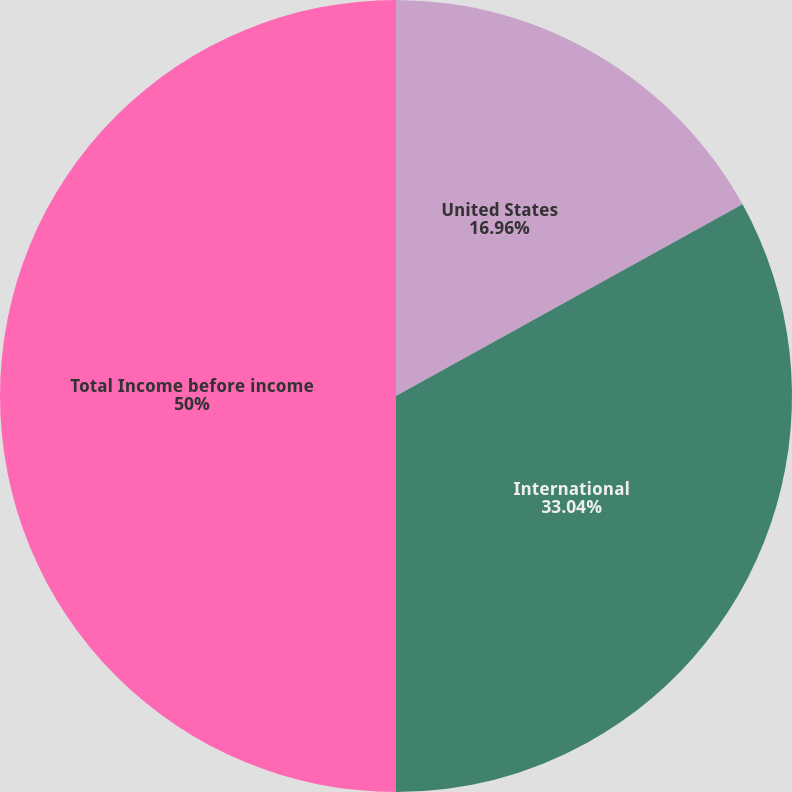<chart> <loc_0><loc_0><loc_500><loc_500><pie_chart><fcel>United States<fcel>International<fcel>Total Income before income<nl><fcel>16.96%<fcel>33.04%<fcel>50.0%<nl></chart> 